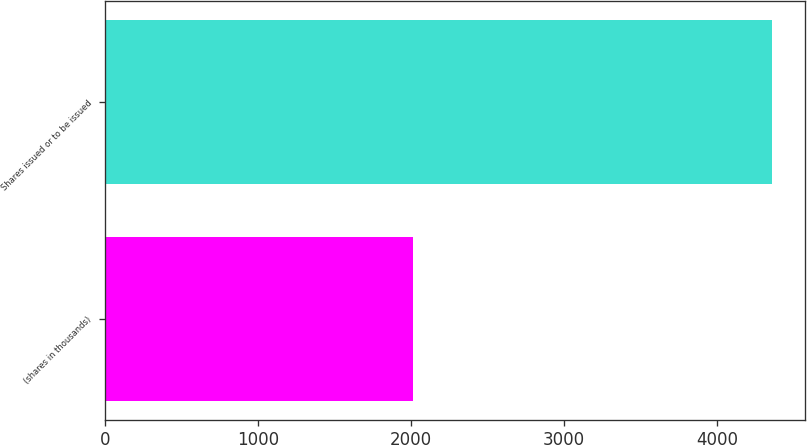Convert chart. <chart><loc_0><loc_0><loc_500><loc_500><bar_chart><fcel>(shares in thousands)<fcel>Shares issued or to be issued<nl><fcel>2010<fcel>4358<nl></chart> 